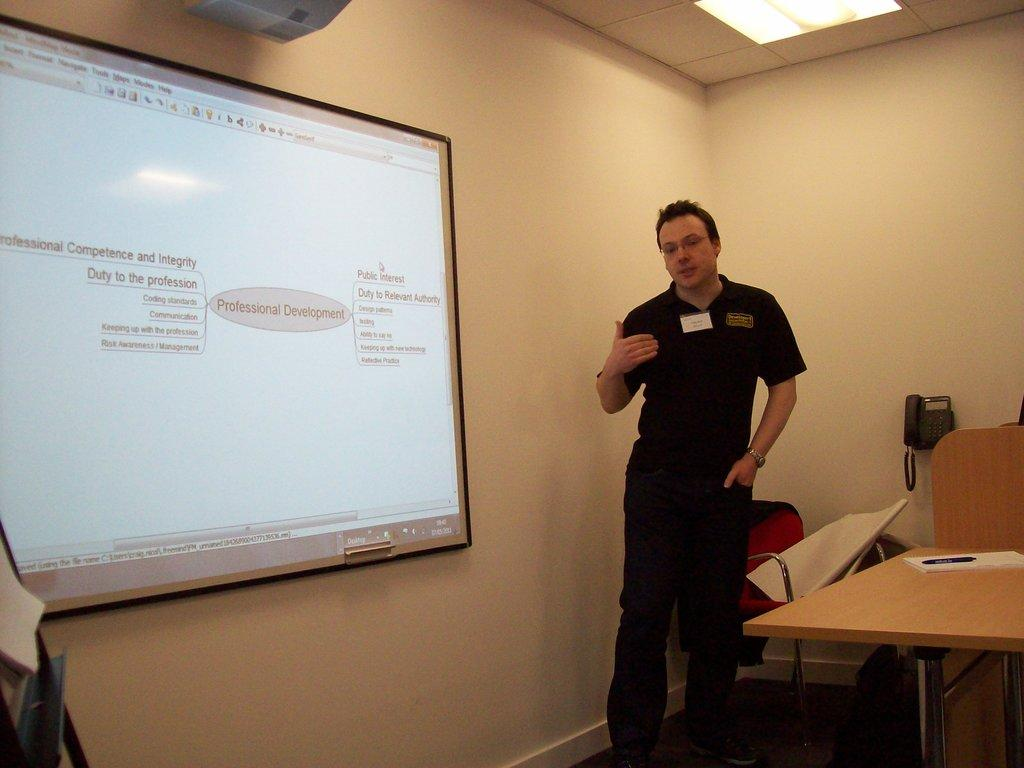What is the man in the image doing? The man is standing and speaking in the image. What can be seen on the board in the image? There is a projector light on the board. What piece of furniture is present in the image? There is a table in the image. What communication device is visible in the image? There is a telephone in the image. What type of clam is being used as a paperweight on the table in the image? There is no clam present in the image; it is a telephone on the table. How many tickets can be seen in the image? There are no tickets present in the image. 